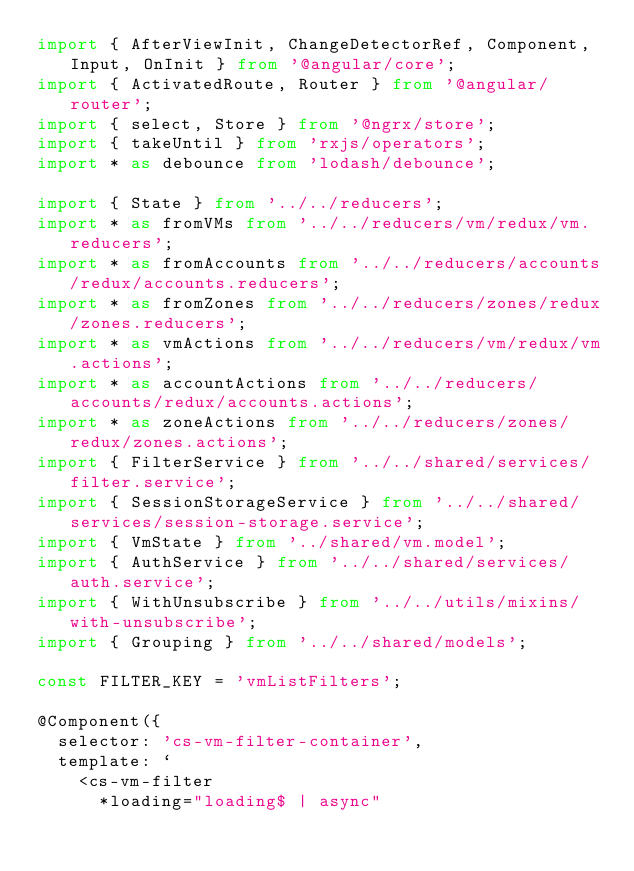<code> <loc_0><loc_0><loc_500><loc_500><_TypeScript_>import { AfterViewInit, ChangeDetectorRef, Component, Input, OnInit } from '@angular/core';
import { ActivatedRoute, Router } from '@angular/router';
import { select, Store } from '@ngrx/store';
import { takeUntil } from 'rxjs/operators';
import * as debounce from 'lodash/debounce';

import { State } from '../../reducers';
import * as fromVMs from '../../reducers/vm/redux/vm.reducers';
import * as fromAccounts from '../../reducers/accounts/redux/accounts.reducers';
import * as fromZones from '../../reducers/zones/redux/zones.reducers';
import * as vmActions from '../../reducers/vm/redux/vm.actions';
import * as accountActions from '../../reducers/accounts/redux/accounts.actions';
import * as zoneActions from '../../reducers/zones/redux/zones.actions';
import { FilterService } from '../../shared/services/filter.service';
import { SessionStorageService } from '../../shared/services/session-storage.service';
import { VmState } from '../shared/vm.model';
import { AuthService } from '../../shared/services/auth.service';
import { WithUnsubscribe } from '../../utils/mixins/with-unsubscribe';
import { Grouping } from '../../shared/models';

const FILTER_KEY = 'vmListFilters';

@Component({
  selector: 'cs-vm-filter-container',
  template: `
    <cs-vm-filter
      *loading="loading$ | async"</code> 